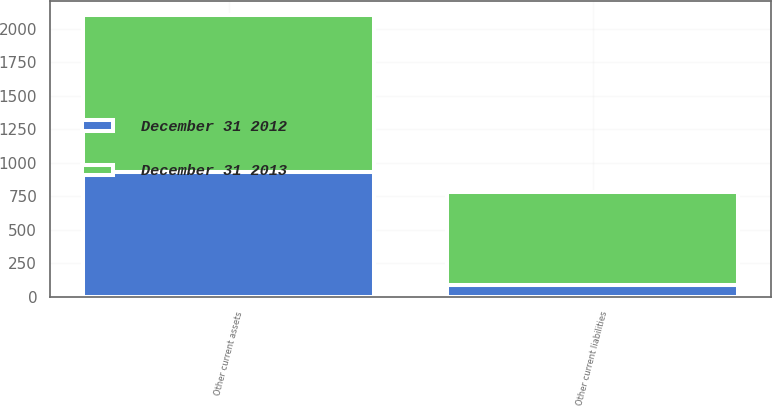<chart> <loc_0><loc_0><loc_500><loc_500><stacked_bar_chart><ecel><fcel>Other current assets<fcel>Other current liabilities<nl><fcel>December 31 2012<fcel>929<fcel>88<nl><fcel>December 31 2013<fcel>1173<fcel>693<nl></chart> 